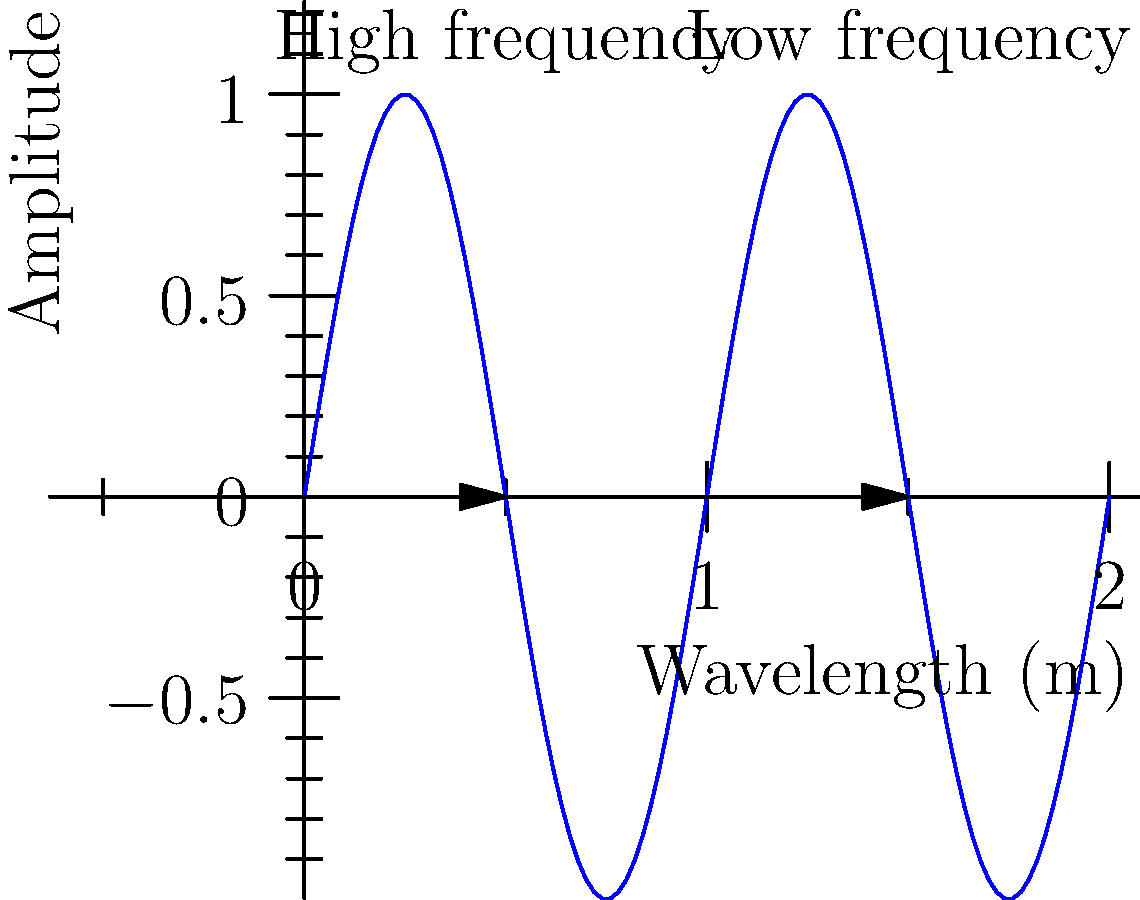As a progressive jazz musician exploring the physics of sound, how would you describe the relationship between frequency and wavelength based on the sine wave graph shown? How might this understanding influence your approach to composing or collaborating with artists from diverse musical backgrounds? To understand the relationship between frequency and wavelength in sound waves:

1. Observe the graph: The blue sine wave represents a sound wave, with wavelength on the x-axis and amplitude on the y-axis.

2. Compare the labeled sections:
   - "High frequency" section has more cycles in a given distance
   - "Low frequency" section has fewer cycles in the same distance

3. Understand the relationship:
   - Frequency (f) is the number of cycles per second
   - Wavelength (λ) is the distance between two consecutive peaks or troughs

4. Apply the wave equation: $$v = f λ$$
   Where v is the speed of sound (constant in a given medium)

5. Deduce the inverse relationship: As frequency increases, wavelength decreases, and vice versa.

6. Musical application:
   - Higher pitch notes correspond to higher frequencies and shorter wavelengths
   - Lower pitch notes correspond to lower frequencies and longer wavelengths

7. Collaboration insight: Understanding this relationship allows for better communication and experimentation with artists from diverse backgrounds, as it provides a common language to discuss pitch, timbre, and sound manipulation across different musical traditions and instruments.
Answer: Inverse relationship; higher frequency = shorter wavelength, lower frequency = longer wavelength. Enables cross-genre collaboration through shared understanding of sound physics. 